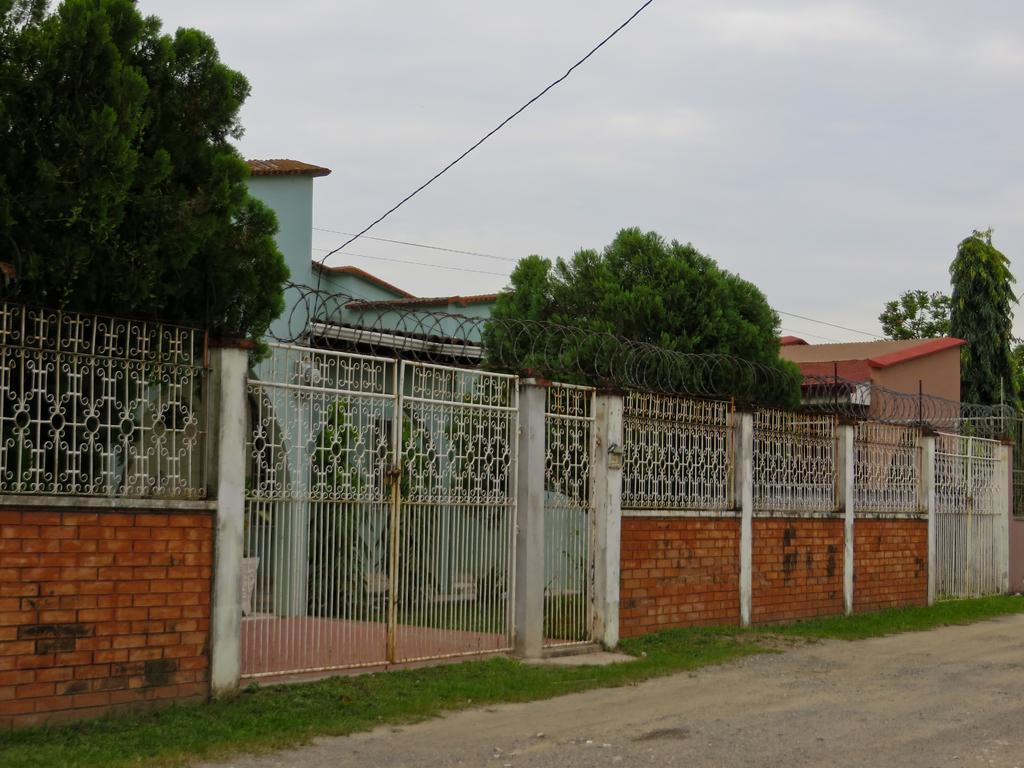Please provide a concise description of this image. In this image we can see buildings, fencing, gate, wall, trees and sky. 